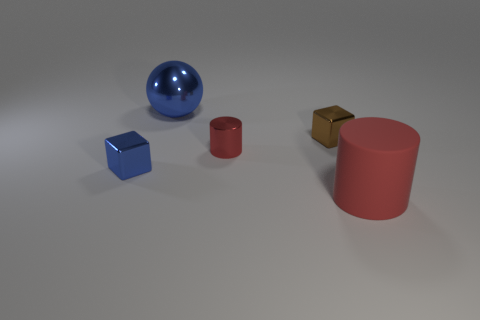Add 2 metal cubes. How many objects exist? 7 Subtract all tiny blue cubes. Subtract all big red metallic balls. How many objects are left? 4 Add 5 blue objects. How many blue objects are left? 7 Add 3 large red objects. How many large red objects exist? 4 Subtract 0 gray cubes. How many objects are left? 5 Subtract all spheres. How many objects are left? 4 